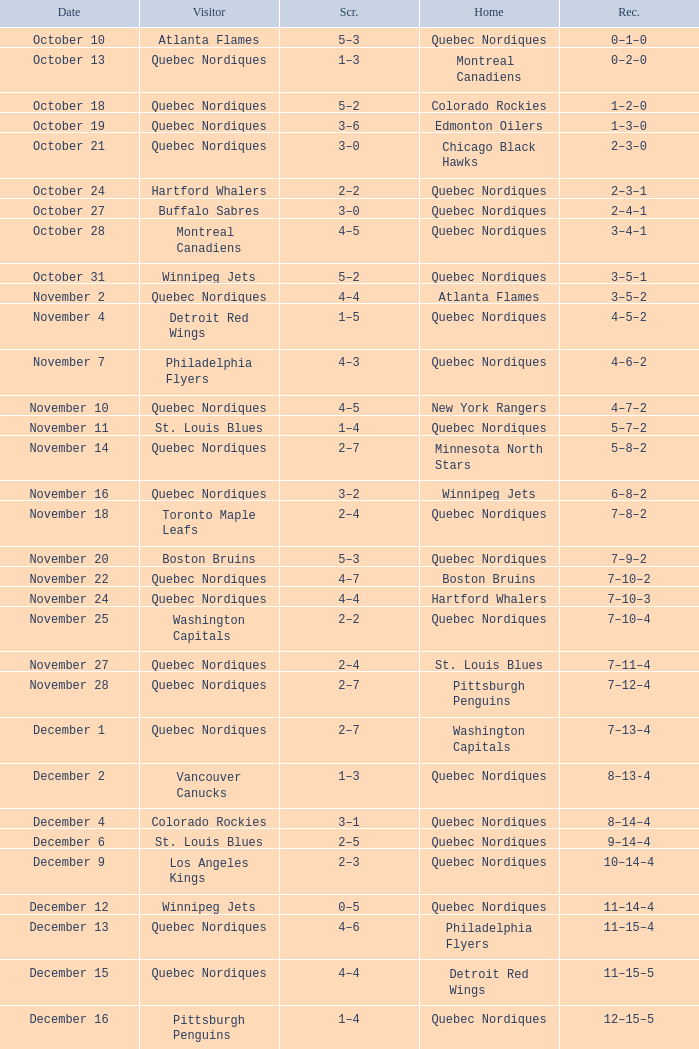Which Record has a Home of edmonton oilers, and a Score of 3–6? 1–3–0. 